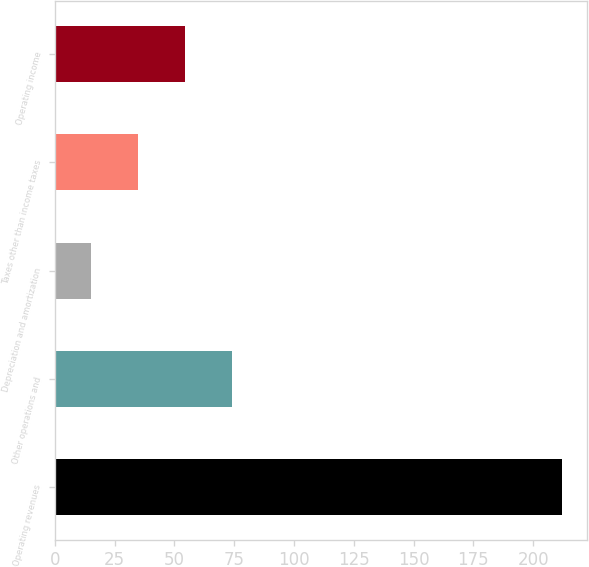Convert chart to OTSL. <chart><loc_0><loc_0><loc_500><loc_500><bar_chart><fcel>Operating revenues<fcel>Other operations and<fcel>Depreciation and amortization<fcel>Taxes other than income taxes<fcel>Operating income<nl><fcel>212<fcel>74.1<fcel>15<fcel>34.7<fcel>54.4<nl></chart> 